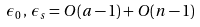<formula> <loc_0><loc_0><loc_500><loc_500>\epsilon _ { 0 } \, , \, \epsilon _ { s } = O ( a - 1 ) + O ( n - 1 ) \\</formula> 